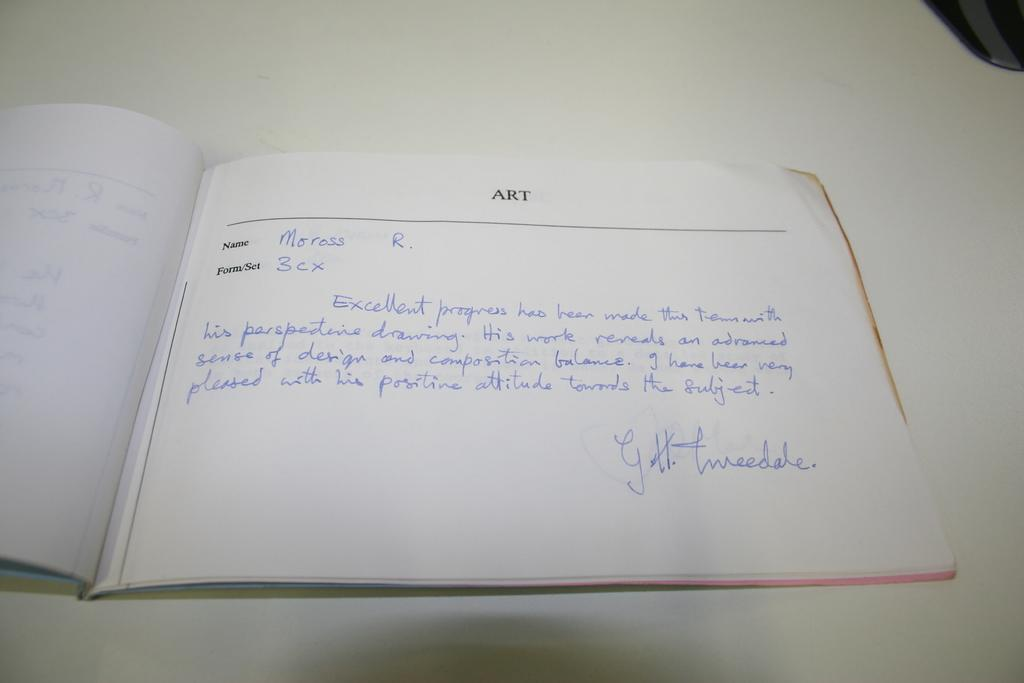<image>
Write a terse but informative summary of the picture. A notebook with the word ART at the top has something written by Moross R. in it. 